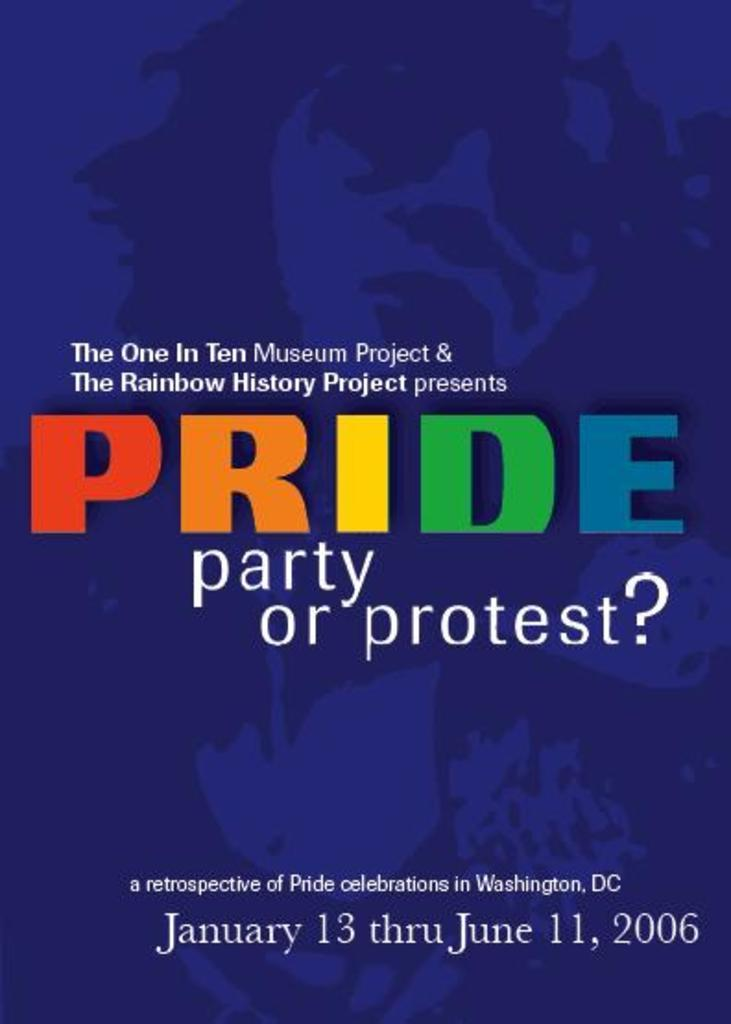What is present in the image that has text on it? There is a poster in the image that has text written on it. Can you describe the poster in the image? The poster in the image has text written on it. How many sisters are depicted on the poster in the image? There are no sisters depicted on the poster in the image, as the facts provided only mention that the poster has text written on it. 